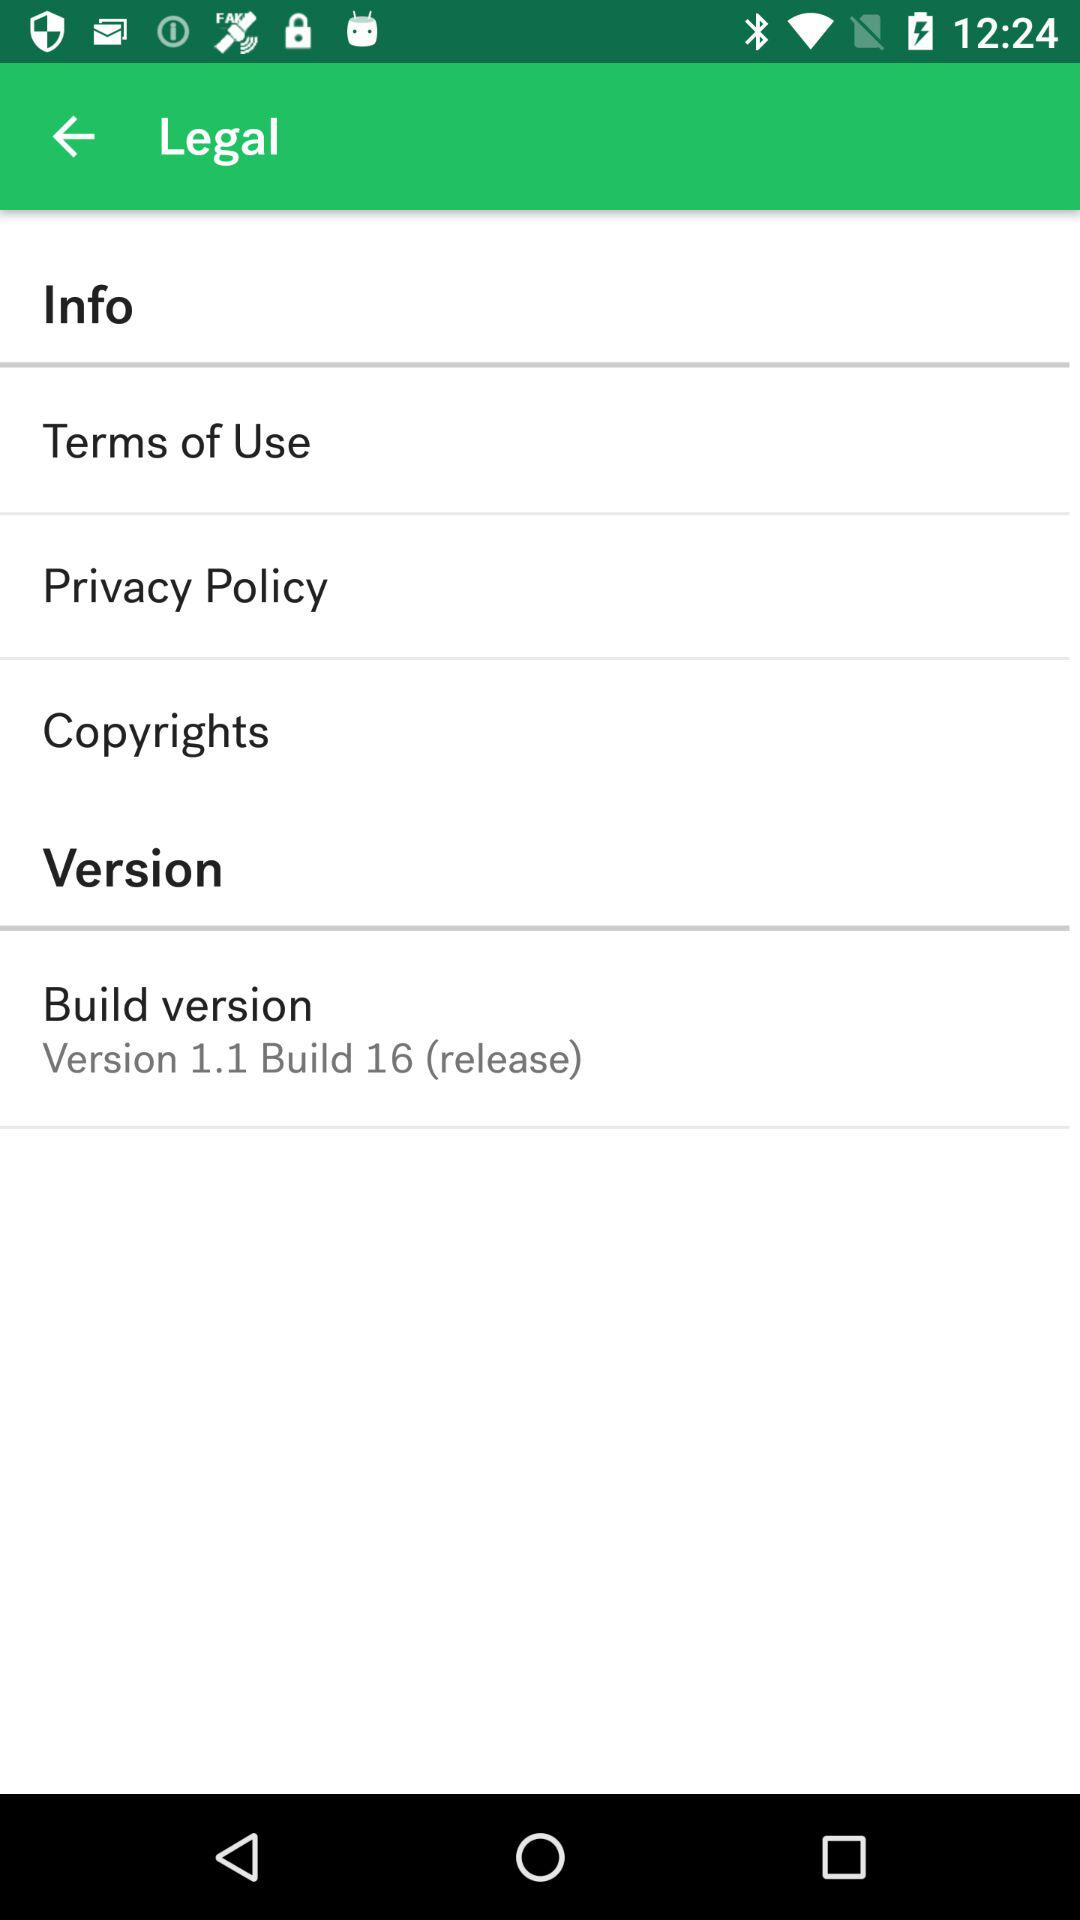What is the build version of the application? The build version is "Version 1.1 Build 16 (release)". 